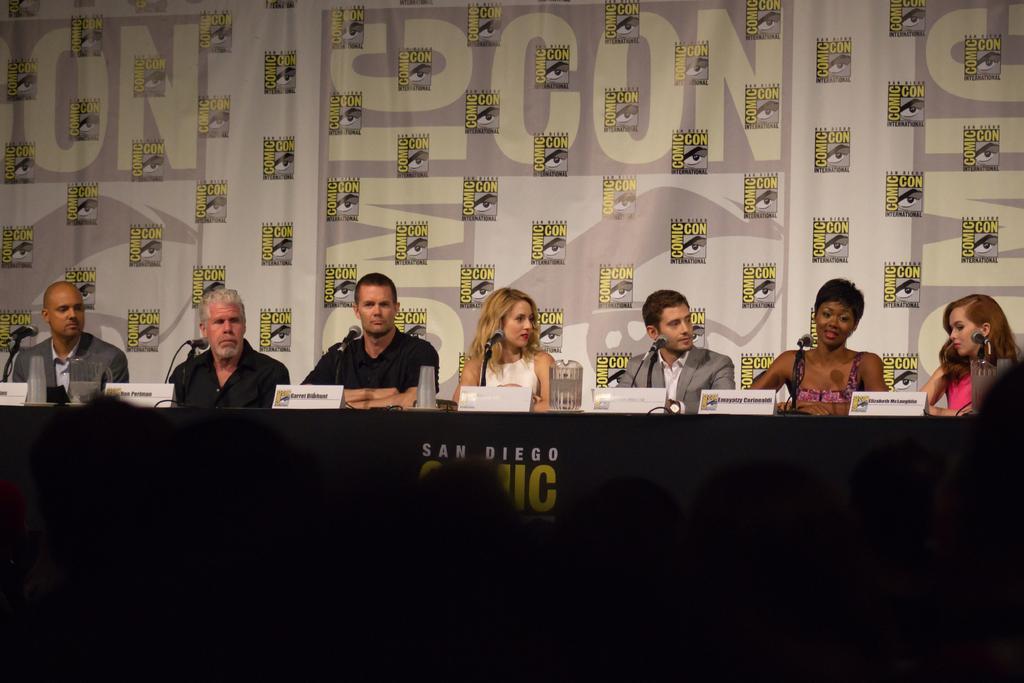Please provide a concise description of this image. In this image I can see a table , on the table I can see miles and glasses and in front of the table I can see persons , at the top I can see colorful design fence at the bottom I can see dark view. 